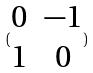<formula> <loc_0><loc_0><loc_500><loc_500>( \begin{matrix} 0 & - 1 \\ 1 & 0 \end{matrix} )</formula> 